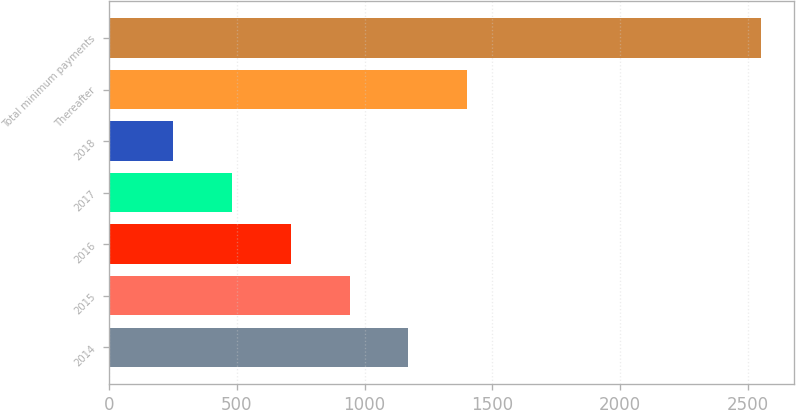<chart> <loc_0><loc_0><loc_500><loc_500><bar_chart><fcel>2014<fcel>2015<fcel>2016<fcel>2017<fcel>2018<fcel>Thereafter<fcel>Total minimum payments<nl><fcel>1171.6<fcel>941.2<fcel>710.8<fcel>480.4<fcel>250<fcel>1402<fcel>2554<nl></chart> 